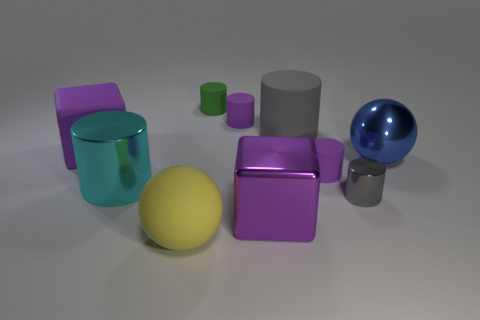Subtract 3 cylinders. How many cylinders are left? 3 Subtract all small gray cylinders. How many cylinders are left? 5 Subtract all green cylinders. How many cylinders are left? 5 Subtract all green cylinders. Subtract all purple spheres. How many cylinders are left? 5 Subtract all spheres. How many objects are left? 8 Subtract all big yellow balls. Subtract all big blue spheres. How many objects are left? 8 Add 9 purple rubber cubes. How many purple rubber cubes are left? 10 Add 2 big brown rubber objects. How many big brown rubber objects exist? 2 Subtract 0 red spheres. How many objects are left? 10 